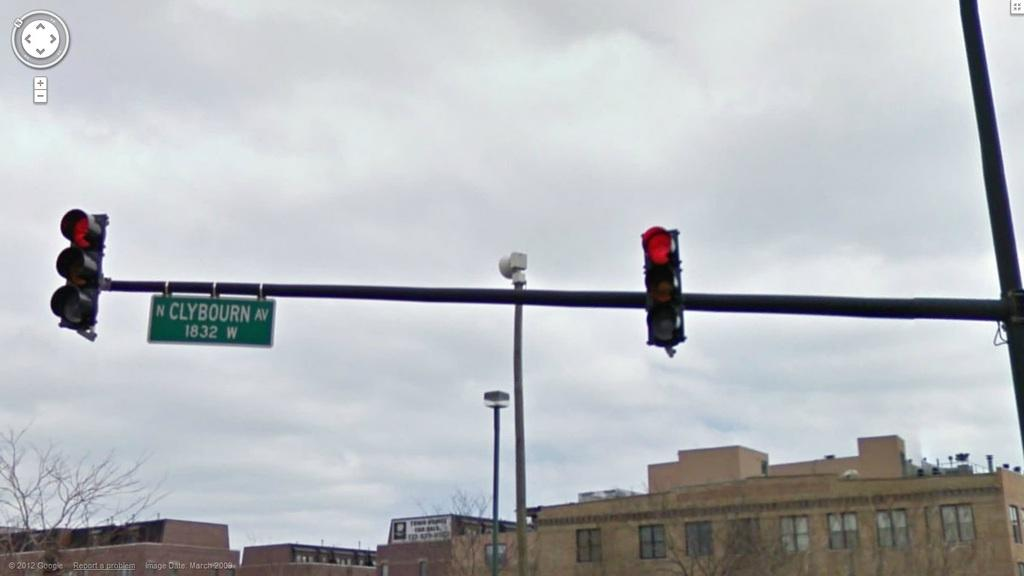<image>
Write a terse but informative summary of the picture. a sign for Clybourn Av between two red traffic lights 